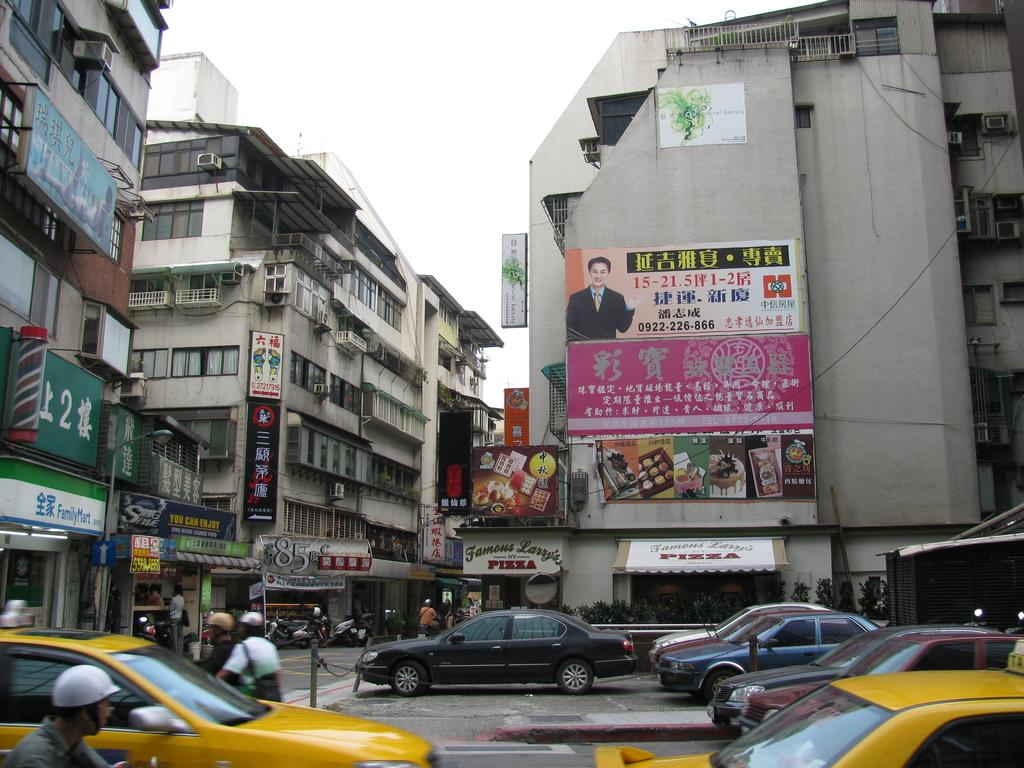<image>
Share a concise interpretation of the image provided. a sign that has the word famous on it 